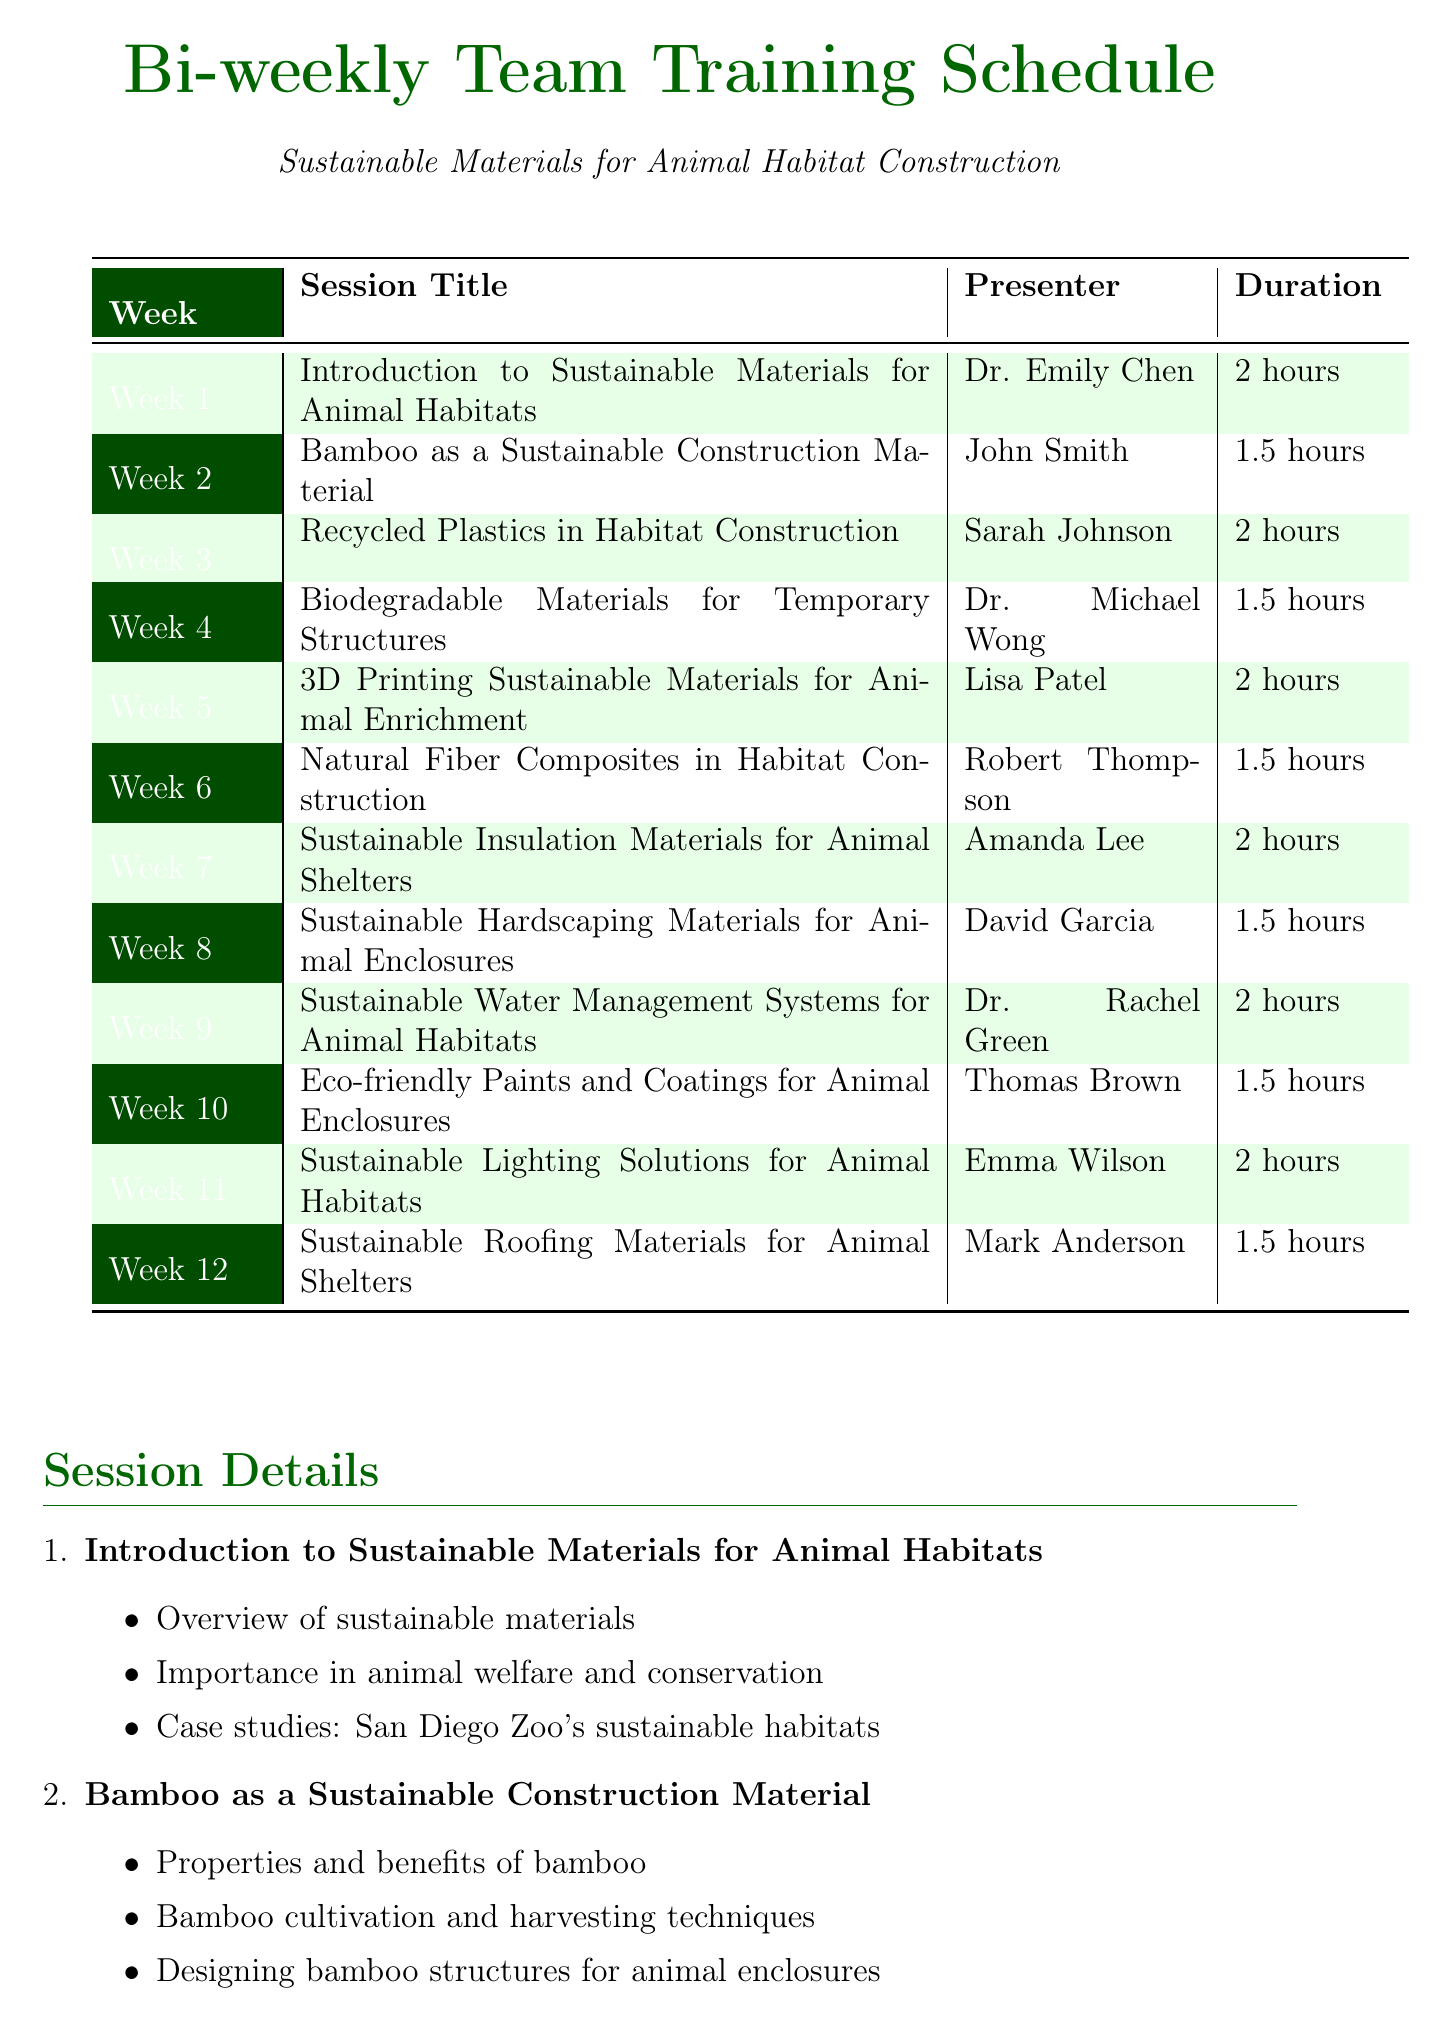what is the title of the first training session? The title of the first training session is listed in the document under "Session Title" for Week 1.
Answer: Introduction to Sustainable Materials for Animal Habitats who is the presenter for the session on recycled plastics? The presenter for the recycled plastics session can be found in the corresponding row for Week 3 in the schedule.
Answer: Sarah Johnson how long is the session on bamboo construction? The duration of the bamboo construction session is specified in the table for Week 2.
Answer: 1.5 hours which week covers sustainable insulation materials? The week corresponding to sustainable insulation materials is indicated in the schedule under "Session Title".
Answer: Week 7 name one topic covered in the session about biodegradable materials. One topic can be found in the bullet points listed under "Biodegradable Materials for Temporary Structures".
Answer: Overview of biodegradable materials who presents the session on sustainable water management systems? The presenter's name is located next to the session title for sustainable water management systems in Week 9.
Answer: Dr. Rachel Green what is the duration of the session on 3D printing? The duration for the 3D printing session can be found in the table under Week 5.
Answer: 2 hours which session is focused on eco-friendly paints? The session focused on eco-friendly paints is located in the corresponding week in the schedule.
Answer: Eco-friendly Paints and Coatings for Animal Enclosures 